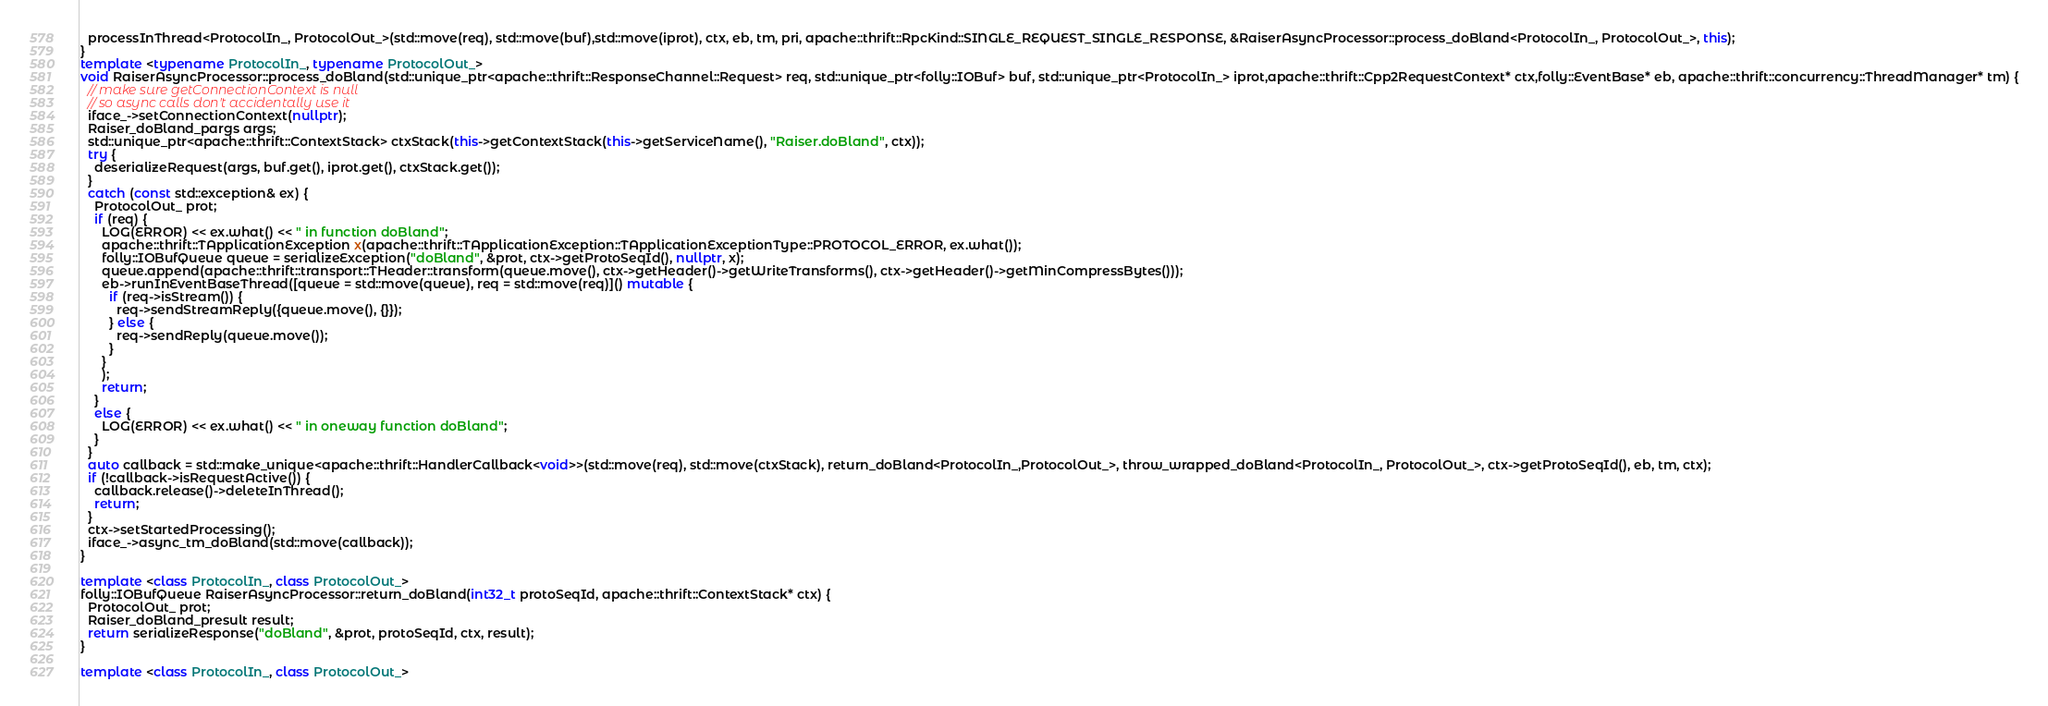<code> <loc_0><loc_0><loc_500><loc_500><_C++_>  processInThread<ProtocolIn_, ProtocolOut_>(std::move(req), std::move(buf),std::move(iprot), ctx, eb, tm, pri, apache::thrift::RpcKind::SINGLE_REQUEST_SINGLE_RESPONSE, &RaiserAsyncProcessor::process_doBland<ProtocolIn_, ProtocolOut_>, this);
}
template <typename ProtocolIn_, typename ProtocolOut_>
void RaiserAsyncProcessor::process_doBland(std::unique_ptr<apache::thrift::ResponseChannel::Request> req, std::unique_ptr<folly::IOBuf> buf, std::unique_ptr<ProtocolIn_> iprot,apache::thrift::Cpp2RequestContext* ctx,folly::EventBase* eb, apache::thrift::concurrency::ThreadManager* tm) {
  // make sure getConnectionContext is null
  // so async calls don't accidentally use it
  iface_->setConnectionContext(nullptr);
  Raiser_doBland_pargs args;
  std::unique_ptr<apache::thrift::ContextStack> ctxStack(this->getContextStack(this->getServiceName(), "Raiser.doBland", ctx));
  try {
    deserializeRequest(args, buf.get(), iprot.get(), ctxStack.get());
  }
  catch (const std::exception& ex) {
    ProtocolOut_ prot;
    if (req) {
      LOG(ERROR) << ex.what() << " in function doBland";
      apache::thrift::TApplicationException x(apache::thrift::TApplicationException::TApplicationExceptionType::PROTOCOL_ERROR, ex.what());
      folly::IOBufQueue queue = serializeException("doBland", &prot, ctx->getProtoSeqId(), nullptr, x);
      queue.append(apache::thrift::transport::THeader::transform(queue.move(), ctx->getHeader()->getWriteTransforms(), ctx->getHeader()->getMinCompressBytes()));
      eb->runInEventBaseThread([queue = std::move(queue), req = std::move(req)]() mutable {
        if (req->isStream()) {
          req->sendStreamReply({queue.move(), {}});
        } else {
          req->sendReply(queue.move());
        }
      }
      );
      return;
    }
    else {
      LOG(ERROR) << ex.what() << " in oneway function doBland";
    }
  }
  auto callback = std::make_unique<apache::thrift::HandlerCallback<void>>(std::move(req), std::move(ctxStack), return_doBland<ProtocolIn_,ProtocolOut_>, throw_wrapped_doBland<ProtocolIn_, ProtocolOut_>, ctx->getProtoSeqId(), eb, tm, ctx);
  if (!callback->isRequestActive()) {
    callback.release()->deleteInThread();
    return;
  }
  ctx->setStartedProcessing();
  iface_->async_tm_doBland(std::move(callback));
}

template <class ProtocolIn_, class ProtocolOut_>
folly::IOBufQueue RaiserAsyncProcessor::return_doBland(int32_t protoSeqId, apache::thrift::ContextStack* ctx) {
  ProtocolOut_ prot;
  Raiser_doBland_presult result;
  return serializeResponse("doBland", &prot, protoSeqId, ctx, result);
}

template <class ProtocolIn_, class ProtocolOut_></code> 